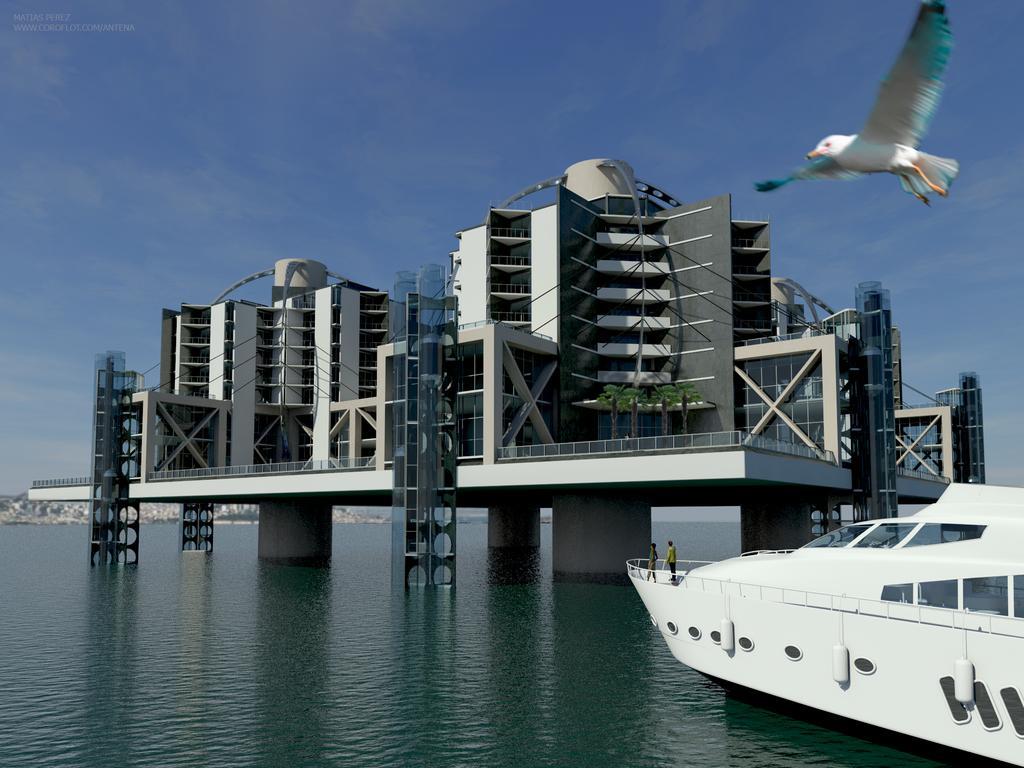In one or two sentences, can you explain what this image depicts? To the right corner of the image there is a ship with glass windows, railing and two persons are standing in front of the ship. And the ship is in the water. To the bottom middle of the ship there is water. In the middle of the water there is a building with pillars, poles and glass windows. To the right top corner of the image there is a bird flying. And to the top of the image there is a sky. 